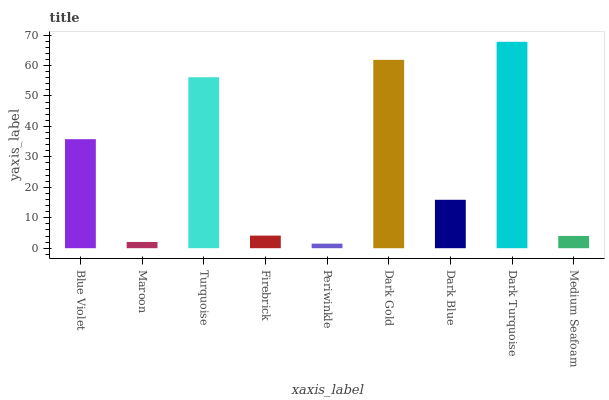Is Periwinkle the minimum?
Answer yes or no. Yes. Is Dark Turquoise the maximum?
Answer yes or no. Yes. Is Maroon the minimum?
Answer yes or no. No. Is Maroon the maximum?
Answer yes or no. No. Is Blue Violet greater than Maroon?
Answer yes or no. Yes. Is Maroon less than Blue Violet?
Answer yes or no. Yes. Is Maroon greater than Blue Violet?
Answer yes or no. No. Is Blue Violet less than Maroon?
Answer yes or no. No. Is Dark Blue the high median?
Answer yes or no. Yes. Is Dark Blue the low median?
Answer yes or no. Yes. Is Periwinkle the high median?
Answer yes or no. No. Is Turquoise the low median?
Answer yes or no. No. 